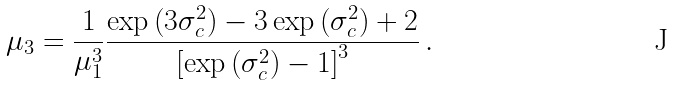<formula> <loc_0><loc_0><loc_500><loc_500>\mu _ { 3 } = \frac { 1 } { \mu _ { 1 } ^ { 3 } } \frac { \exp \left ( 3 \sigma _ { c } ^ { 2 } \right ) - 3 \exp \left ( \sigma _ { c } ^ { 2 } \right ) + 2 } { \left [ \exp \left ( \sigma _ { c } ^ { 2 } \right ) - 1 \right ] ^ { 3 } } \, .</formula> 